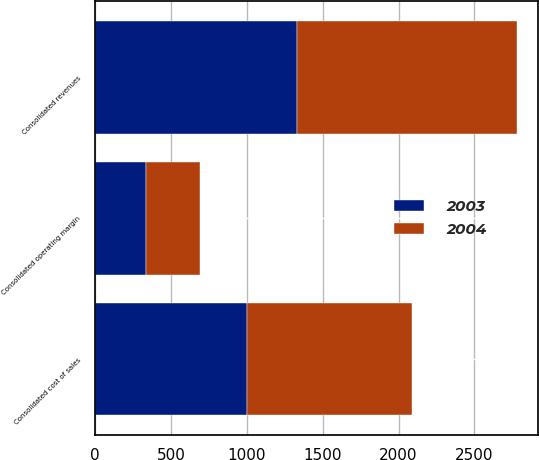<chart> <loc_0><loc_0><loc_500><loc_500><stacked_bar_chart><ecel><fcel>Consolidated revenues<fcel>Consolidated cost of sales<fcel>Consolidated operating margin<nl><fcel>2003<fcel>1333.3<fcel>997.7<fcel>335.6<nl><fcel>2004<fcel>1446.5<fcel>1092.8<fcel>353.7<nl></chart> 